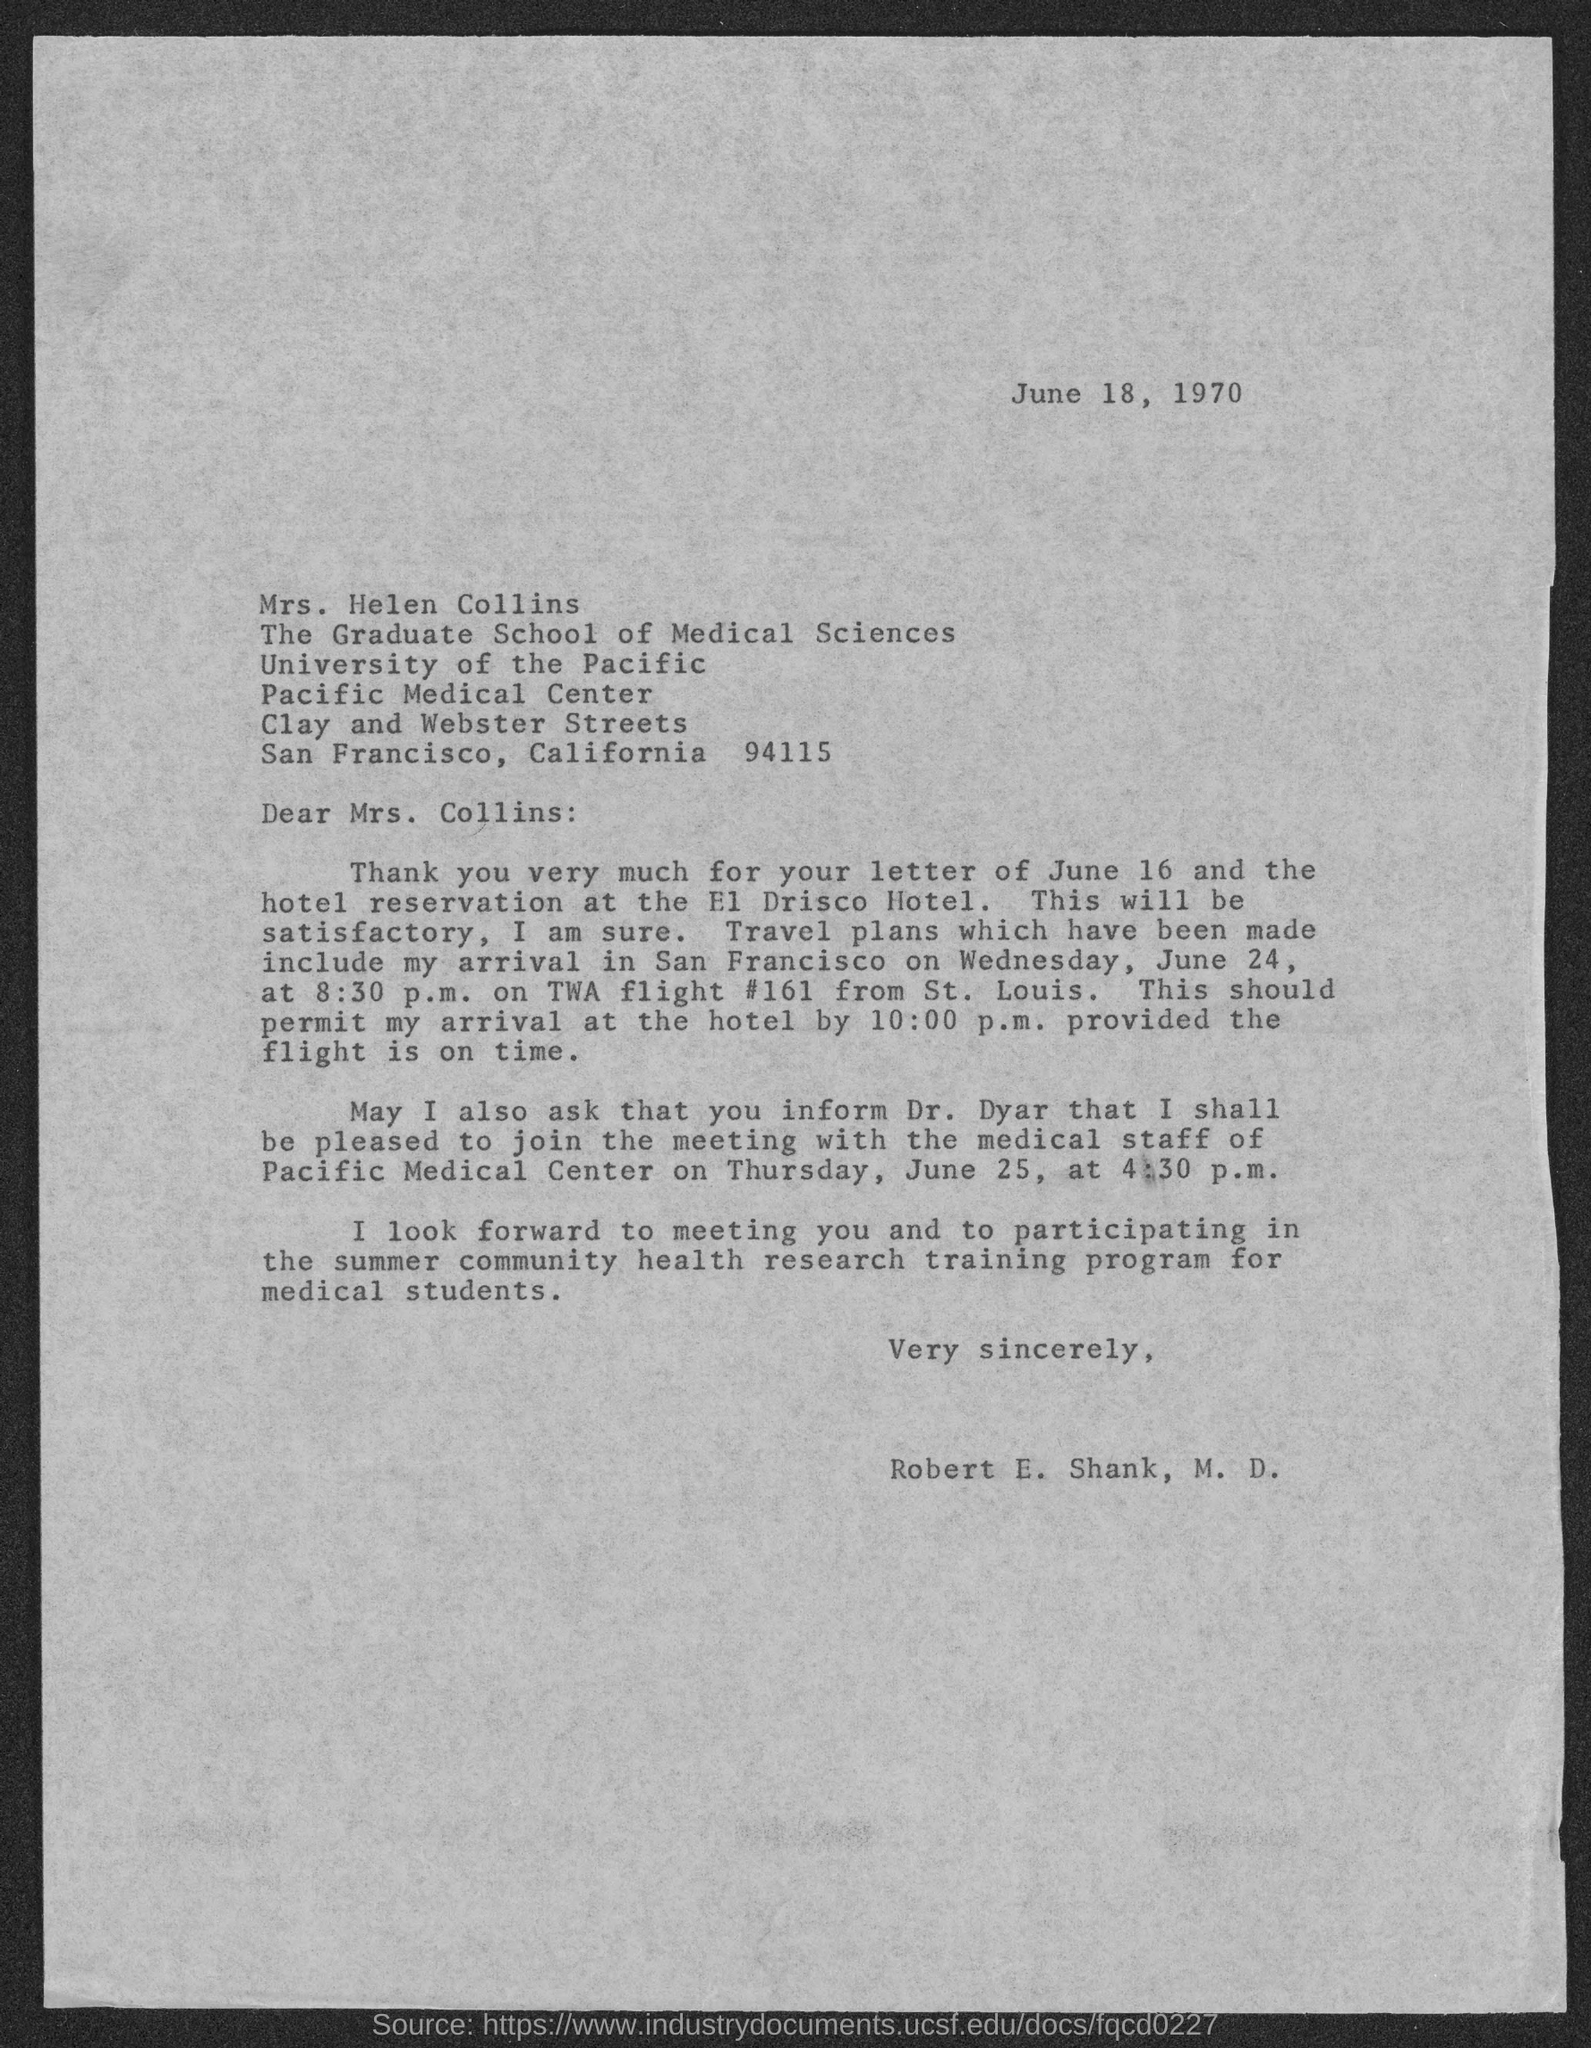To whom this letter is written to?
Your response must be concise. Mrs. Helen Collins. Who wrote this letter?
Offer a terse response. Robert E. Shank, M.D. Where is this twa flight #161 coming  from?
Your answer should be compact. St. Louis. 